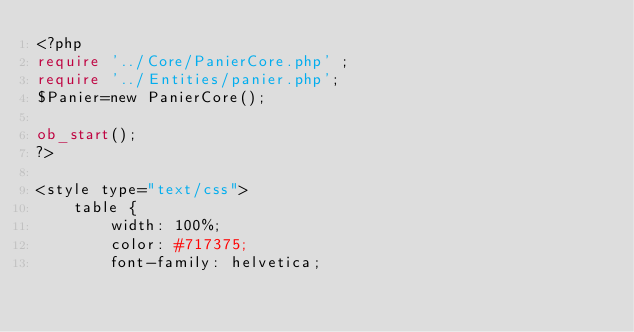Convert code to text. <code><loc_0><loc_0><loc_500><loc_500><_PHP_><?php
require '../Core/PanierCore.php' ;
require '../Entities/panier.php';
$Panier=new PanierCore();

ob_start();
?>

<style type="text/css">
    table {
        width: 100%;
        color: #717375;
        font-family: helvetica;</code> 